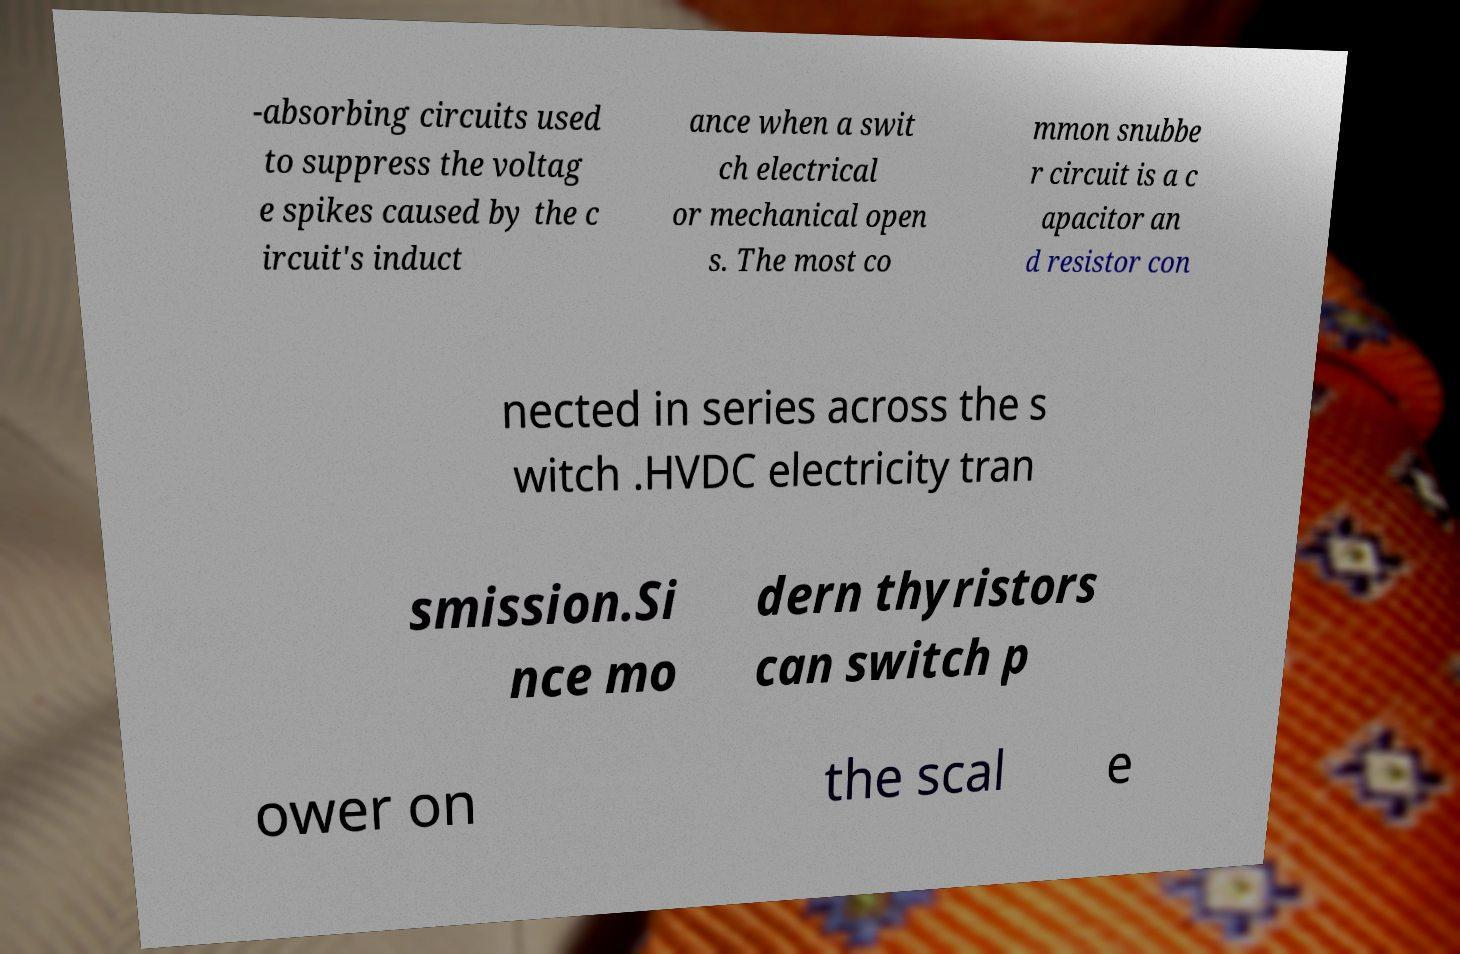Can you read and provide the text displayed in the image?This photo seems to have some interesting text. Can you extract and type it out for me? -absorbing circuits used to suppress the voltag e spikes caused by the c ircuit's induct ance when a swit ch electrical or mechanical open s. The most co mmon snubbe r circuit is a c apacitor an d resistor con nected in series across the s witch .HVDC electricity tran smission.Si nce mo dern thyristors can switch p ower on the scal e 